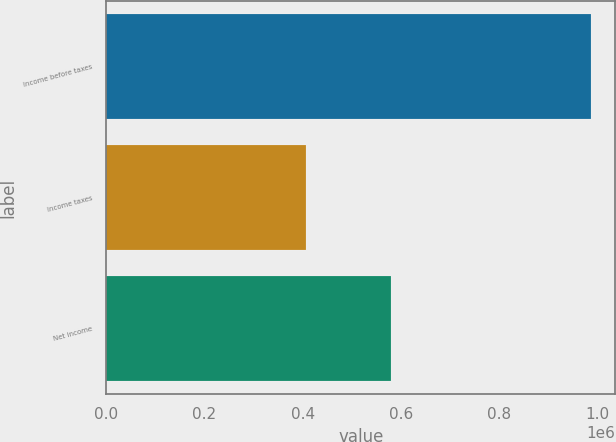Convert chart. <chart><loc_0><loc_0><loc_500><loc_500><bar_chart><fcel>Income before taxes<fcel>Income taxes<fcel>Net income<nl><fcel>987097<fcel>407005<fcel>580092<nl></chart> 